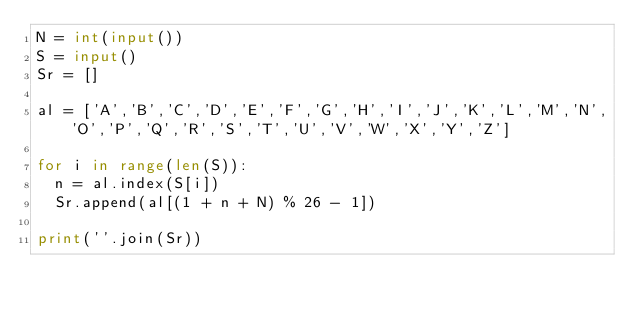<code> <loc_0><loc_0><loc_500><loc_500><_Python_>N = int(input())
S = input()
Sr = []

al = ['A','B','C','D','E','F','G','H','I','J','K','L','M','N','O','P','Q','R','S','T','U','V','W','X','Y','Z']

for i in range(len(S)):
  n = al.index(S[i])
  Sr.append(al[(1 + n + N) % 26 - 1])
  
print(''.join(Sr))</code> 